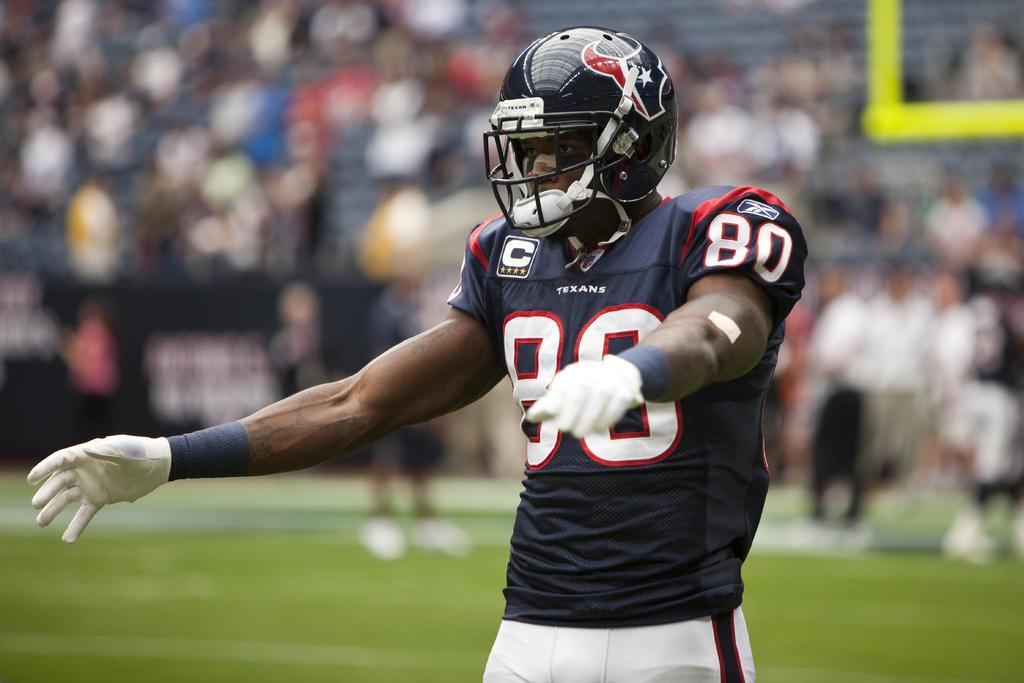What is the main subject of the image? There is a player in the image. What protective gear is the player wearing? The player is wearing a helmet. Can you describe the background of the image? The background of the image is blurred. Are there any other people visible in the image? Yes, there are people visible in the background. What is the surface on which the player is standing? The ground is visible in the image. What type of cable is being used by the player to expand their abilities in the image? There is no cable present in the image, and the player's abilities are not being expanded. How does the player's laughter affect the other people in the image? There is no indication of the player laughing in the image, and therefore, it cannot be determined how their laughter would affect the other people. 